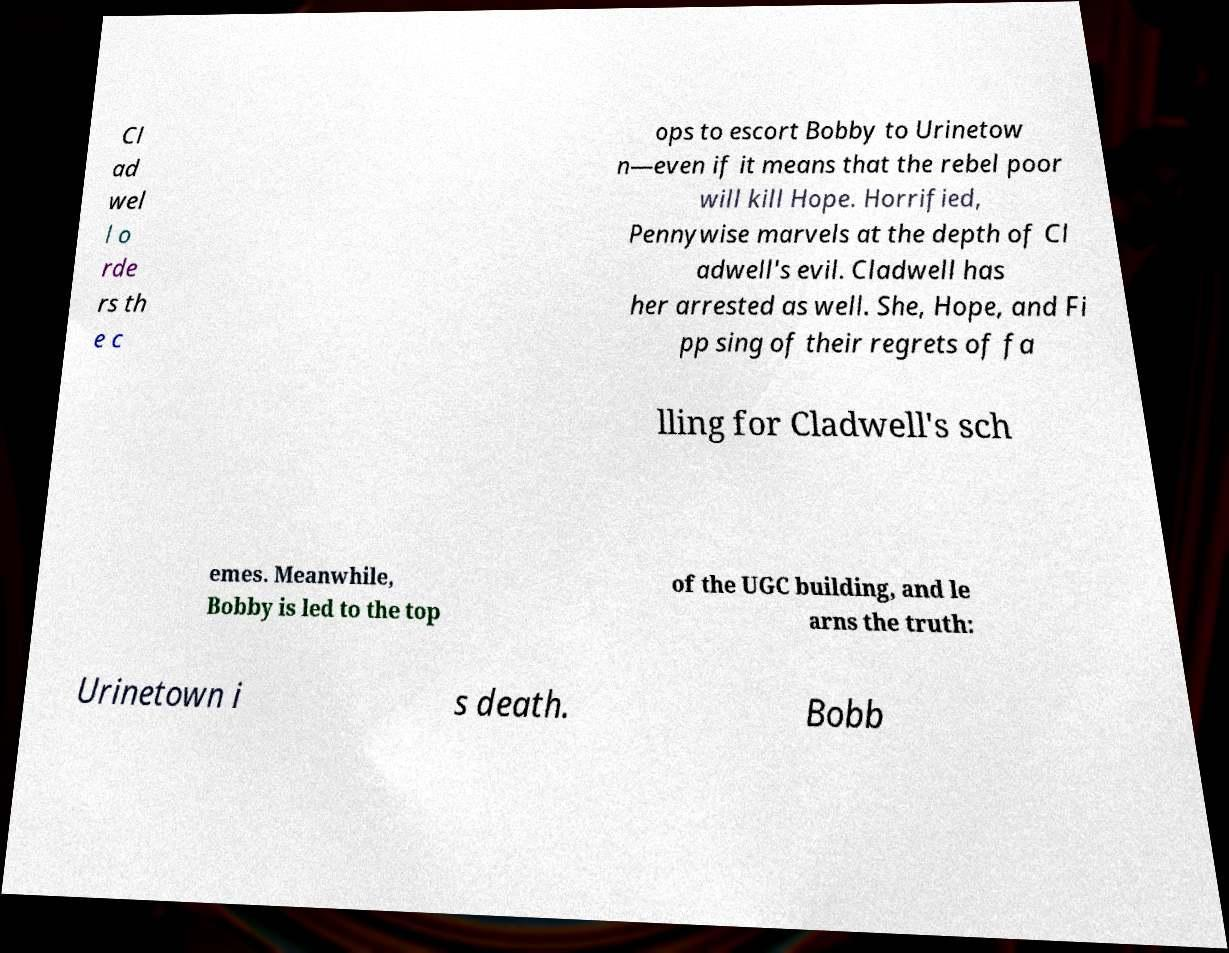I need the written content from this picture converted into text. Can you do that? Cl ad wel l o rde rs th e c ops to escort Bobby to Urinetow n—even if it means that the rebel poor will kill Hope. Horrified, Pennywise marvels at the depth of Cl adwell's evil. Cladwell has her arrested as well. She, Hope, and Fi pp sing of their regrets of fa lling for Cladwell's sch emes. Meanwhile, Bobby is led to the top of the UGC building, and le arns the truth: Urinetown i s death. Bobb 